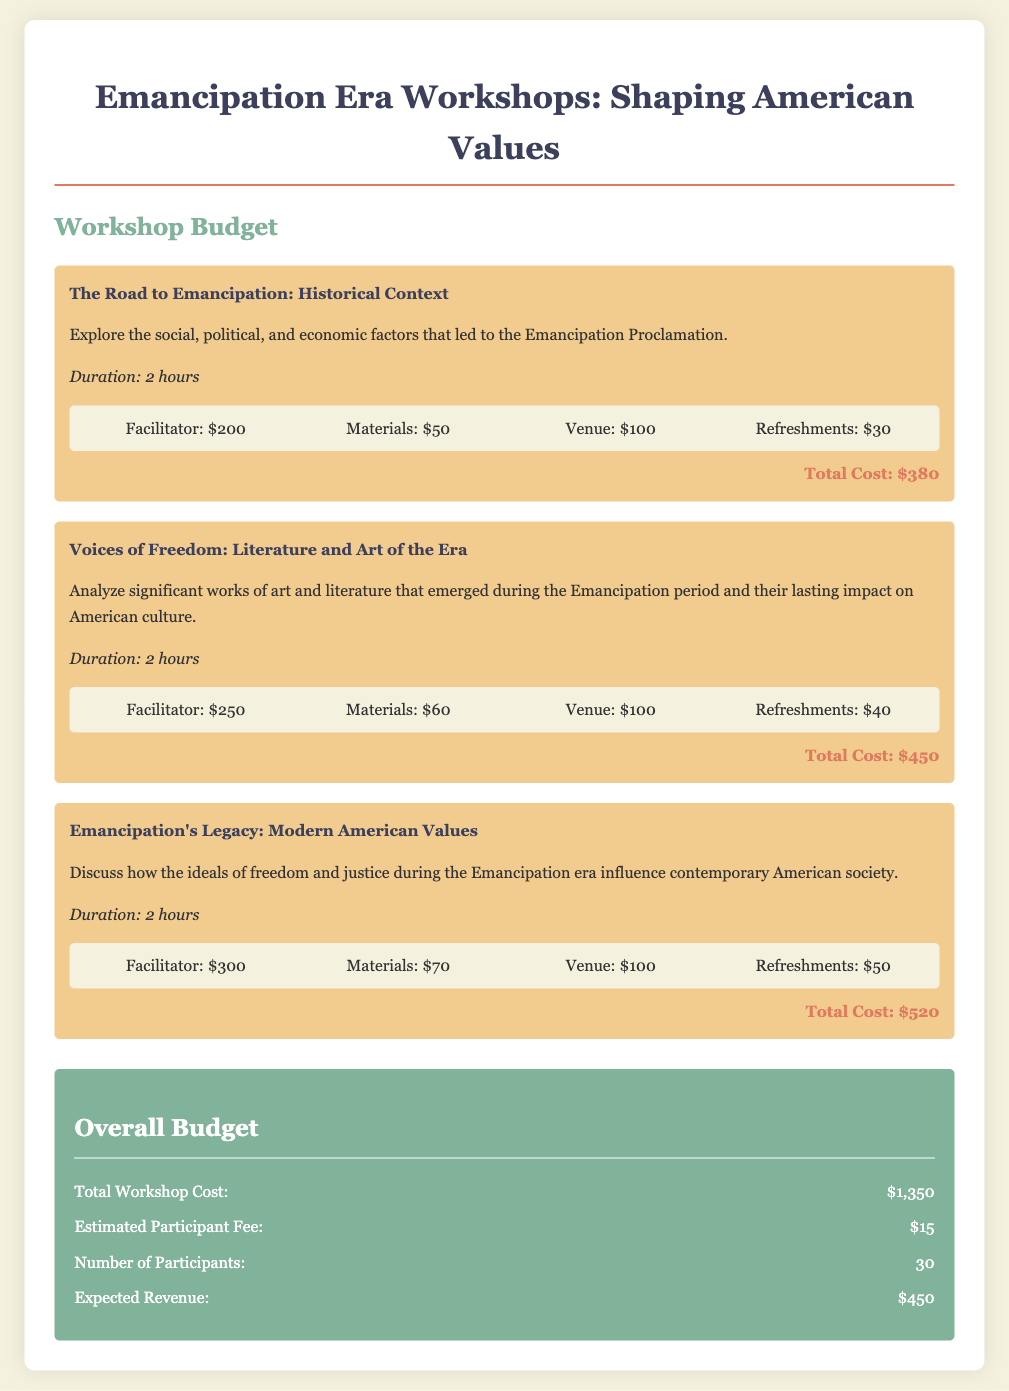What is the total cost of the first workshop? The total cost for the first workshop titled "The Road to Emancipation: Historical Context" is listed as $380.
Answer: $380 What is the duration of the workshop on modern American values? The duration for the workshop titled "Emancipation's Legacy: Modern American Values" is specified as 2 hours.
Answer: 2 hours How much is allocated for materials in the second workshop? The document states that $60 is allocated for materials in the "Voices of Freedom: Literature and Art of the Era" workshop.
Answer: $60 What is the expected revenue from participant fees? The expected revenue is calculated based on the estimated participant fee multiplied by the number of participants, resulting in $450.
Answer: $450 What is the total workshop cost? The total cost for all workshops combined, as listed in the overall budget, is $1,350.
Answer: $1,350 How much are the refreshments for the last workshop? The cost for refreshments for "Emancipation's Legacy: Modern American Values" workshop is noted as $50.
Answer: $50 What is the facilitator fee for the second workshop? The facilitator fee for the second workshop titled "Voices of Freedom: Literature and Art of the Era" is $250.
Answer: $250 What is the cost of the venue for the workshops? The venue cost for each workshop session is consistently noted as $100.
Answer: $100 